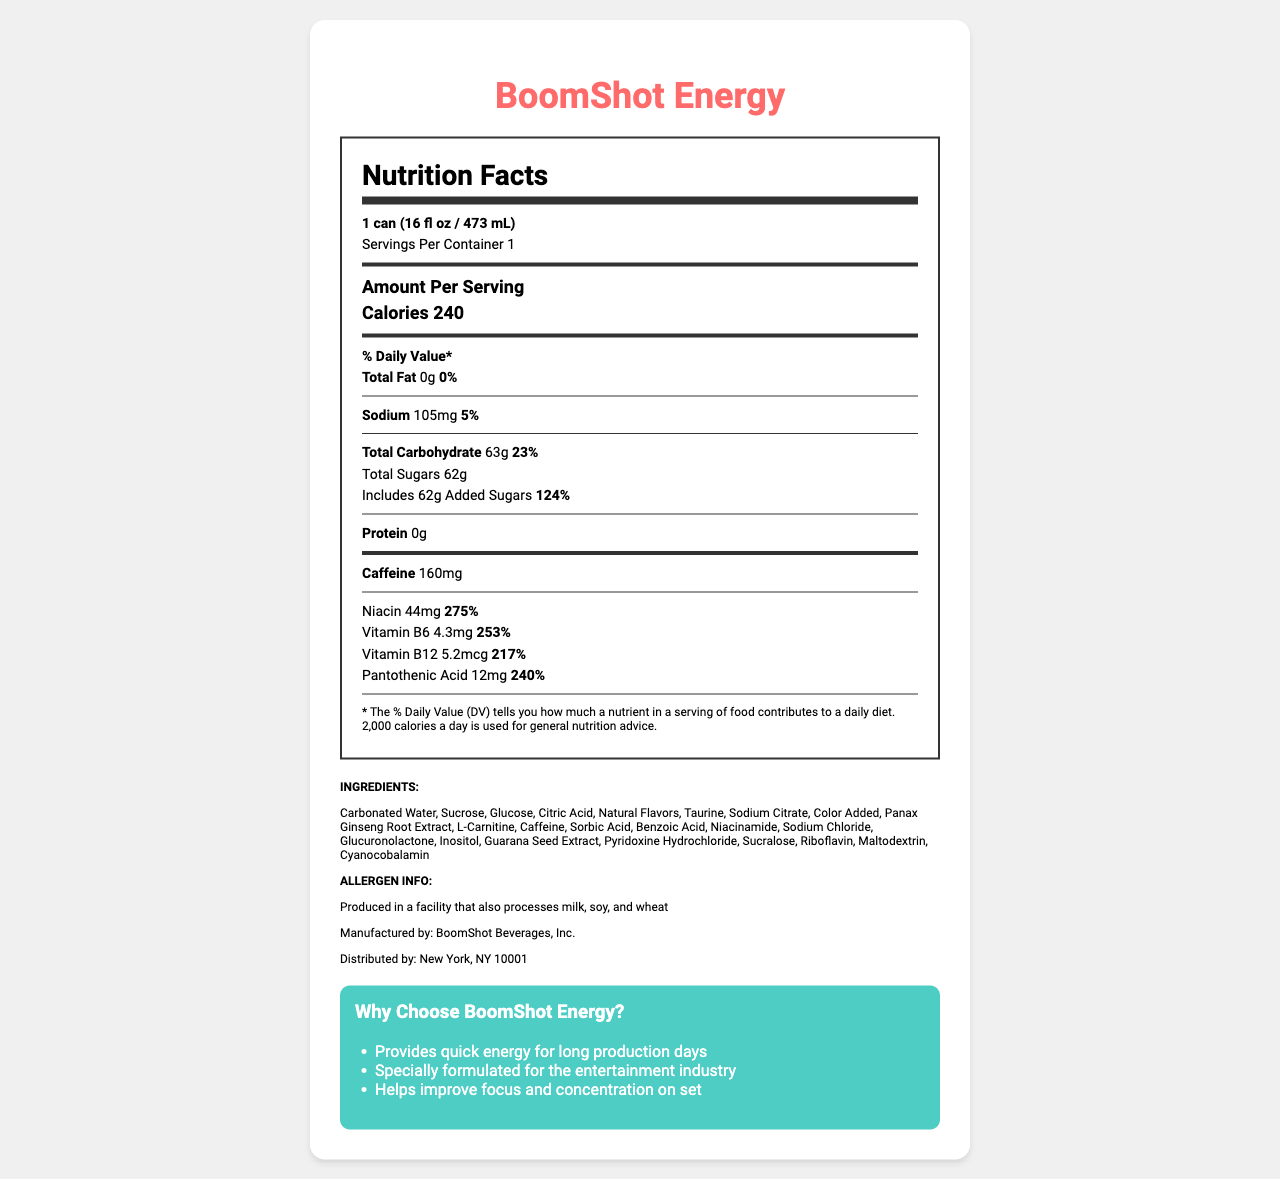What is the serving size of BoomShot Energy? The document specifies the serving size as "1 can (16 fl oz / 473 mL)".
Answer: 1 can (16 fl oz / 473 mL) How many calories are in one serving of BoomShot Energy? The document lists the calorie content as 240 per serving.
Answer: 240 calories What is the total carbohydrate content in one serving? The document indicates that one serving contains 63g of total carbohydrates.
Answer: 63g What is the sodium content and its daily value percentage? The document states that the sodium content is 105mg, which is 5% of the daily value.
Answer: 105mg, 5% DV How much caffeine does BoomShot Energy contain per serving? The document specifies that there is 160mg of caffeine per serving.
Answer: 160mg What is one of the vitamins included in BoomShot Energy and its daily value percentage? A. Niacin - 275% B. Vitamin B12 - 217% C. Pantothenic Acid - 240% D. All of the above All of the listed vitamins are included in BoomShot Energy, with their respective daily value percentages mentioned: Niacin - 275%, Vitamin B12 - 217%, Pantothenic Acid - 240%.
Answer: D. All of the above Which ingredient is NOT listed in BoomShot Energy? 1. Carbonated Water 2. Taurine 3. Ascorbic Acid 4. Maltodextrin The document lists Carbonated Water, Taurine, and Maltodextrin among the ingredients, but not Ascorbic Acid.
Answer: 3. Ascorbic Acid Is BoomShot Energy produced in a facility that processes allergens like milk, soy, and wheat? The document indicates that BoomShot Energy is produced in a facility that also processes milk, soy, and wheat.
Answer: Yes Provide a brief summary of the main idea of this document. The document offers a comprehensive overview of the energy drink's nutritional profile, ingredient list, and manufacturer’s information, along with marketing claims emphasizing its benefits for energy, focus, and concentration.
Answer: The document provides detailed nutritional information for BoomShot Energy, including its serving size, calorie content, vitamin and mineral content, caffeine amount, ingredients, allergen information, manufacturing details, and marketing claims. What is the manufacturer of BoomShot Energy? The document specifies that BoomShot Energy is manufactured by BoomShot Beverages, Inc.
Answer: BoomShot Beverages, Inc. Which vitamin in BoomShot Energy has the highest daily value percentage? Niacin has the highest daily value percentage of 275%, as indicated in the document.
Answer: Niacin, 275% Can you provide details on the daily value percentage for Vitamin C in BoomShot Energy? The document does not mention Vitamin C or its daily value percentage.
Answer: Not enough information Which marketing claims are made about BoomShot Energy? The document lists three specific marketing claims: providing quick energy, being specially formulated for the entertainment industry, and improving focus and concentration.
Answer: Provides quick energy for long production days, Specially formulated for the entertainment industry, Helps improve focus and concentration on set What is the added sugars content in BoomShot Energy and its daily value? The document indicates that BoomShot Energy contains 62g of added sugars, accounting for 124% of the daily value.
Answer: 62g, 124% DV How many servings are in one container of BoomShot Energy? The document clearly states that there is 1 serving per container.
Answer: 1 